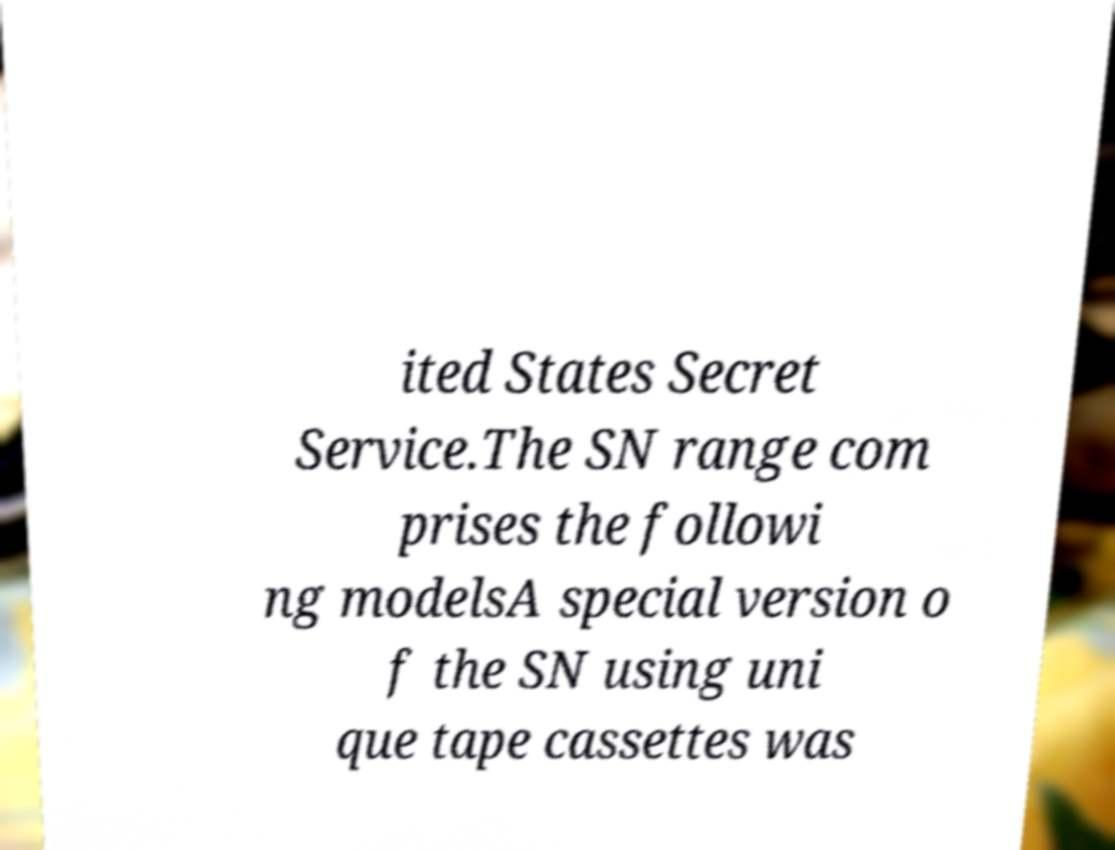Could you assist in decoding the text presented in this image and type it out clearly? ited States Secret Service.The SN range com prises the followi ng modelsA special version o f the SN using uni que tape cassettes was 